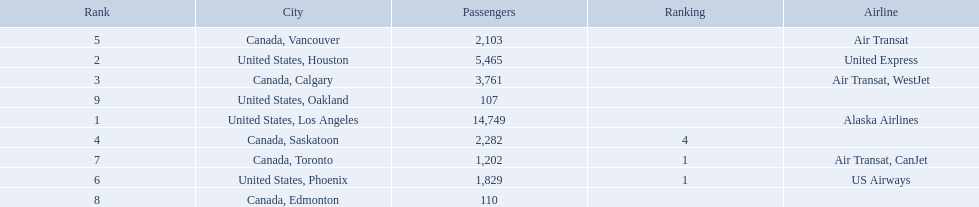Where are the destinations of the airport? United States, Los Angeles, United States, Houston, Canada, Calgary, Canada, Saskatoon, Canada, Vancouver, United States, Phoenix, Canada, Toronto, Canada, Edmonton, United States, Oakland. What is the number of passengers to phoenix? 1,829. 